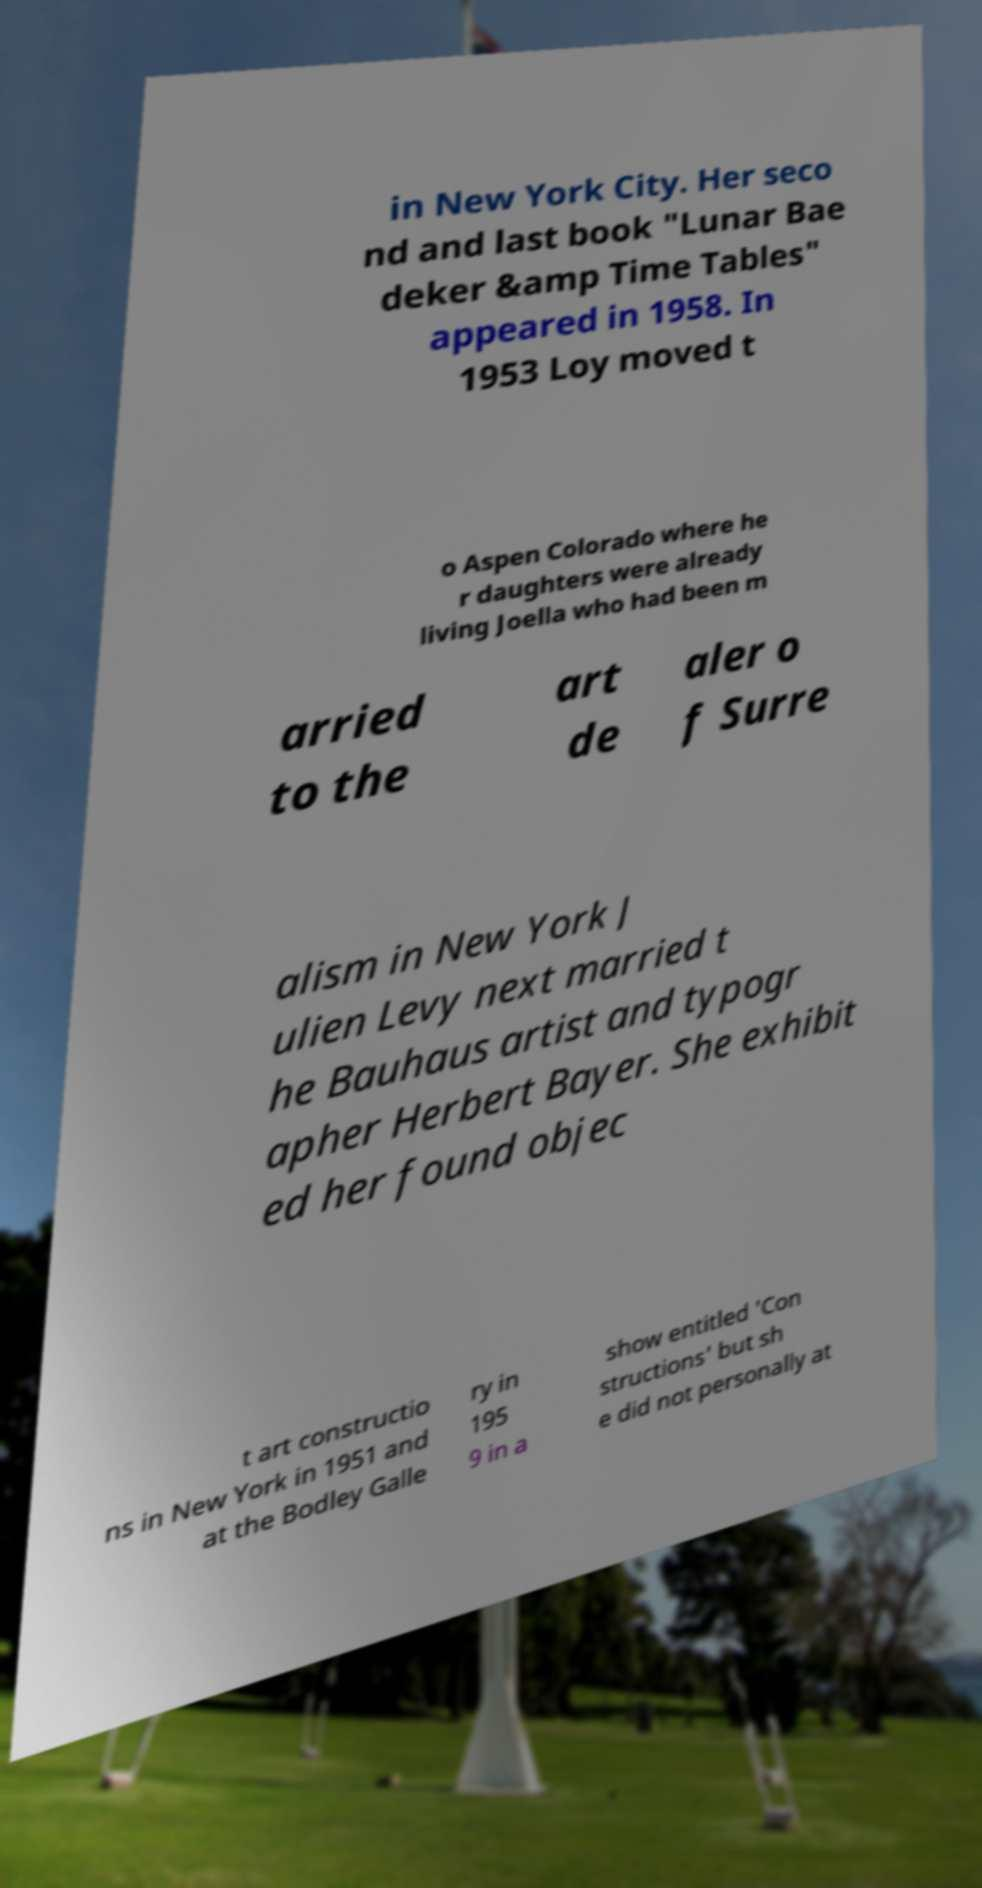Can you read and provide the text displayed in the image?This photo seems to have some interesting text. Can you extract and type it out for me? in New York City. Her seco nd and last book "Lunar Bae deker &amp Time Tables" appeared in 1958. In 1953 Loy moved t o Aspen Colorado where he r daughters were already living Joella who had been m arried to the art de aler o f Surre alism in New York J ulien Levy next married t he Bauhaus artist and typogr apher Herbert Bayer. She exhibit ed her found objec t art constructio ns in New York in 1951 and at the Bodley Galle ry in 195 9 in a show entitled 'Con structions' but sh e did not personally at 